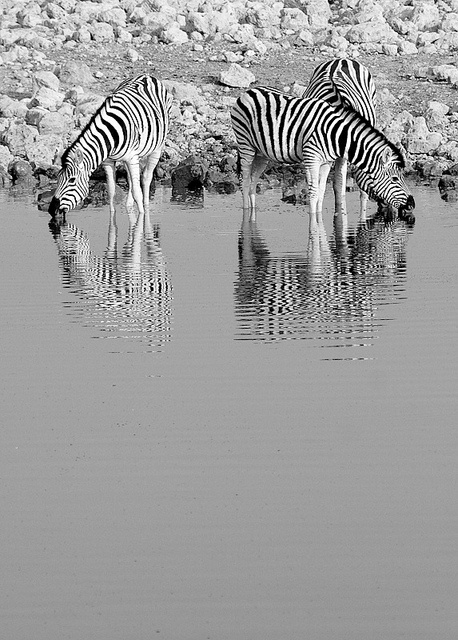Describe the objects in this image and their specific colors. I can see zebra in lightgray, black, darkgray, and gray tones, zebra in lightgray, white, black, darkgray, and gray tones, and zebra in lightgray, white, black, darkgray, and gray tones in this image. 